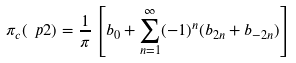<formula> <loc_0><loc_0><loc_500><loc_500>\pi _ { c } ( \ p 2 ) = \frac { 1 } { \pi } \left [ b _ { 0 } + \sum _ { n = 1 } ^ { \infty } ( - 1 ) ^ { n } ( b _ { 2 n } + b _ { - 2 n } ) \right ]</formula> 